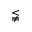<formula> <loc_0><loc_0><loc_500><loc_500>\lneqq</formula> 